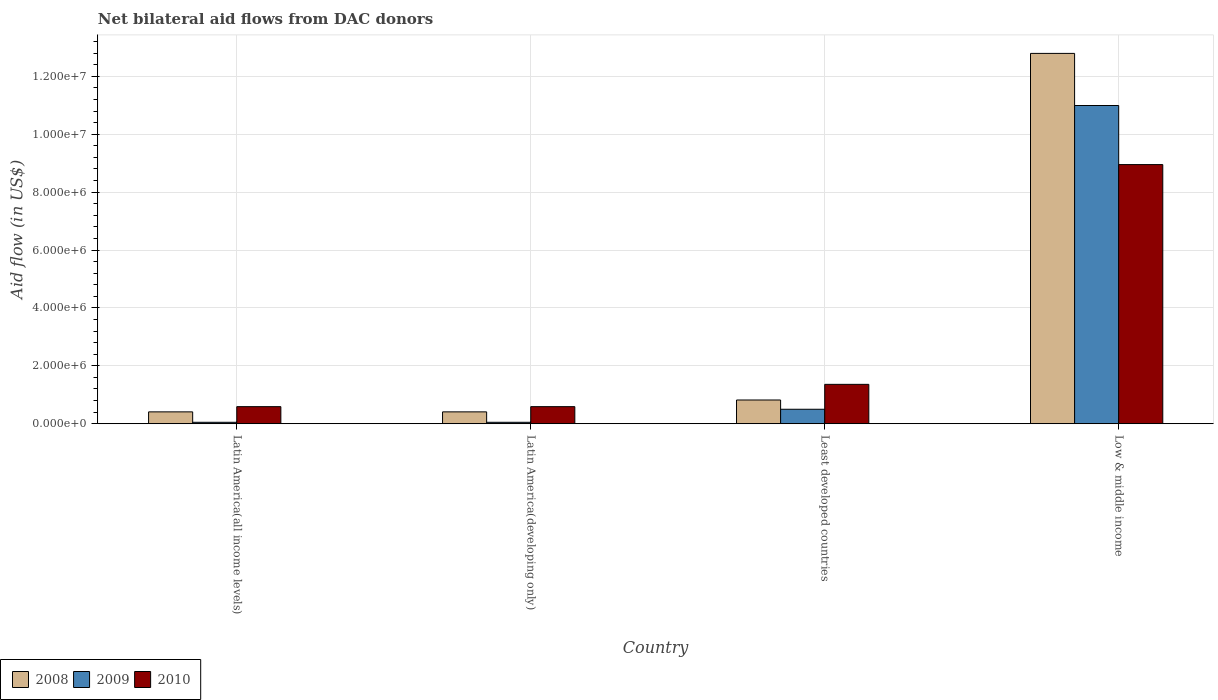How many different coloured bars are there?
Give a very brief answer. 3. How many groups of bars are there?
Your answer should be compact. 4. How many bars are there on the 3rd tick from the right?
Make the answer very short. 3. What is the label of the 1st group of bars from the left?
Keep it short and to the point. Latin America(all income levels). What is the net bilateral aid flow in 2008 in Low & middle income?
Give a very brief answer. 1.28e+07. Across all countries, what is the maximum net bilateral aid flow in 2009?
Ensure brevity in your answer.  1.10e+07. In which country was the net bilateral aid flow in 2008 maximum?
Provide a succinct answer. Low & middle income. In which country was the net bilateral aid flow in 2008 minimum?
Make the answer very short. Latin America(all income levels). What is the total net bilateral aid flow in 2010 in the graph?
Offer a terse response. 1.15e+07. What is the difference between the net bilateral aid flow in 2010 in Latin America(all income levels) and that in Low & middle income?
Provide a succinct answer. -8.36e+06. What is the difference between the net bilateral aid flow in 2008 in Least developed countries and the net bilateral aid flow in 2010 in Latin America(developing only)?
Your answer should be compact. 2.30e+05. What is the average net bilateral aid flow in 2008 per country?
Offer a terse response. 3.61e+06. What is the difference between the net bilateral aid flow of/in 2008 and net bilateral aid flow of/in 2010 in Low & middle income?
Offer a very short reply. 3.84e+06. Is the difference between the net bilateral aid flow in 2008 in Latin America(developing only) and Low & middle income greater than the difference between the net bilateral aid flow in 2010 in Latin America(developing only) and Low & middle income?
Provide a short and direct response. No. What is the difference between the highest and the second highest net bilateral aid flow in 2010?
Make the answer very short. 7.59e+06. What is the difference between the highest and the lowest net bilateral aid flow in 2010?
Offer a very short reply. 8.36e+06. What does the 2nd bar from the left in Least developed countries represents?
Keep it short and to the point. 2009. How many bars are there?
Offer a terse response. 12. Are the values on the major ticks of Y-axis written in scientific E-notation?
Provide a short and direct response. Yes. Where does the legend appear in the graph?
Keep it short and to the point. Bottom left. How are the legend labels stacked?
Make the answer very short. Horizontal. What is the title of the graph?
Make the answer very short. Net bilateral aid flows from DAC donors. Does "1977" appear as one of the legend labels in the graph?
Your response must be concise. No. What is the label or title of the Y-axis?
Your answer should be compact. Aid flow (in US$). What is the Aid flow (in US$) of 2008 in Latin America(all income levels)?
Offer a terse response. 4.10e+05. What is the Aid flow (in US$) in 2010 in Latin America(all income levels)?
Your answer should be compact. 5.90e+05. What is the Aid flow (in US$) in 2008 in Latin America(developing only)?
Make the answer very short. 4.10e+05. What is the Aid flow (in US$) in 2009 in Latin America(developing only)?
Ensure brevity in your answer.  5.00e+04. What is the Aid flow (in US$) in 2010 in Latin America(developing only)?
Ensure brevity in your answer.  5.90e+05. What is the Aid flow (in US$) in 2008 in Least developed countries?
Your answer should be compact. 8.20e+05. What is the Aid flow (in US$) in 2009 in Least developed countries?
Keep it short and to the point. 5.00e+05. What is the Aid flow (in US$) of 2010 in Least developed countries?
Your response must be concise. 1.36e+06. What is the Aid flow (in US$) in 2008 in Low & middle income?
Offer a very short reply. 1.28e+07. What is the Aid flow (in US$) of 2009 in Low & middle income?
Keep it short and to the point. 1.10e+07. What is the Aid flow (in US$) of 2010 in Low & middle income?
Provide a succinct answer. 8.95e+06. Across all countries, what is the maximum Aid flow (in US$) in 2008?
Give a very brief answer. 1.28e+07. Across all countries, what is the maximum Aid flow (in US$) of 2009?
Keep it short and to the point. 1.10e+07. Across all countries, what is the maximum Aid flow (in US$) of 2010?
Offer a terse response. 8.95e+06. Across all countries, what is the minimum Aid flow (in US$) of 2010?
Keep it short and to the point. 5.90e+05. What is the total Aid flow (in US$) in 2008 in the graph?
Your answer should be very brief. 1.44e+07. What is the total Aid flow (in US$) of 2009 in the graph?
Make the answer very short. 1.16e+07. What is the total Aid flow (in US$) in 2010 in the graph?
Provide a succinct answer. 1.15e+07. What is the difference between the Aid flow (in US$) of 2009 in Latin America(all income levels) and that in Latin America(developing only)?
Keep it short and to the point. 0. What is the difference between the Aid flow (in US$) in 2008 in Latin America(all income levels) and that in Least developed countries?
Give a very brief answer. -4.10e+05. What is the difference between the Aid flow (in US$) in 2009 in Latin America(all income levels) and that in Least developed countries?
Offer a very short reply. -4.50e+05. What is the difference between the Aid flow (in US$) of 2010 in Latin America(all income levels) and that in Least developed countries?
Provide a succinct answer. -7.70e+05. What is the difference between the Aid flow (in US$) of 2008 in Latin America(all income levels) and that in Low & middle income?
Give a very brief answer. -1.24e+07. What is the difference between the Aid flow (in US$) in 2009 in Latin America(all income levels) and that in Low & middle income?
Offer a very short reply. -1.09e+07. What is the difference between the Aid flow (in US$) of 2010 in Latin America(all income levels) and that in Low & middle income?
Offer a very short reply. -8.36e+06. What is the difference between the Aid flow (in US$) in 2008 in Latin America(developing only) and that in Least developed countries?
Give a very brief answer. -4.10e+05. What is the difference between the Aid flow (in US$) in 2009 in Latin America(developing only) and that in Least developed countries?
Provide a succinct answer. -4.50e+05. What is the difference between the Aid flow (in US$) of 2010 in Latin America(developing only) and that in Least developed countries?
Offer a terse response. -7.70e+05. What is the difference between the Aid flow (in US$) of 2008 in Latin America(developing only) and that in Low & middle income?
Provide a succinct answer. -1.24e+07. What is the difference between the Aid flow (in US$) of 2009 in Latin America(developing only) and that in Low & middle income?
Provide a short and direct response. -1.09e+07. What is the difference between the Aid flow (in US$) of 2010 in Latin America(developing only) and that in Low & middle income?
Offer a very short reply. -8.36e+06. What is the difference between the Aid flow (in US$) in 2008 in Least developed countries and that in Low & middle income?
Provide a short and direct response. -1.20e+07. What is the difference between the Aid flow (in US$) in 2009 in Least developed countries and that in Low & middle income?
Give a very brief answer. -1.05e+07. What is the difference between the Aid flow (in US$) in 2010 in Least developed countries and that in Low & middle income?
Your response must be concise. -7.59e+06. What is the difference between the Aid flow (in US$) of 2008 in Latin America(all income levels) and the Aid flow (in US$) of 2009 in Latin America(developing only)?
Provide a short and direct response. 3.60e+05. What is the difference between the Aid flow (in US$) of 2009 in Latin America(all income levels) and the Aid flow (in US$) of 2010 in Latin America(developing only)?
Offer a terse response. -5.40e+05. What is the difference between the Aid flow (in US$) in 2008 in Latin America(all income levels) and the Aid flow (in US$) in 2009 in Least developed countries?
Provide a short and direct response. -9.00e+04. What is the difference between the Aid flow (in US$) of 2008 in Latin America(all income levels) and the Aid flow (in US$) of 2010 in Least developed countries?
Keep it short and to the point. -9.50e+05. What is the difference between the Aid flow (in US$) of 2009 in Latin America(all income levels) and the Aid flow (in US$) of 2010 in Least developed countries?
Provide a short and direct response. -1.31e+06. What is the difference between the Aid flow (in US$) in 2008 in Latin America(all income levels) and the Aid flow (in US$) in 2009 in Low & middle income?
Offer a very short reply. -1.06e+07. What is the difference between the Aid flow (in US$) of 2008 in Latin America(all income levels) and the Aid flow (in US$) of 2010 in Low & middle income?
Provide a succinct answer. -8.54e+06. What is the difference between the Aid flow (in US$) in 2009 in Latin America(all income levels) and the Aid flow (in US$) in 2010 in Low & middle income?
Give a very brief answer. -8.90e+06. What is the difference between the Aid flow (in US$) in 2008 in Latin America(developing only) and the Aid flow (in US$) in 2009 in Least developed countries?
Ensure brevity in your answer.  -9.00e+04. What is the difference between the Aid flow (in US$) in 2008 in Latin America(developing only) and the Aid flow (in US$) in 2010 in Least developed countries?
Ensure brevity in your answer.  -9.50e+05. What is the difference between the Aid flow (in US$) of 2009 in Latin America(developing only) and the Aid flow (in US$) of 2010 in Least developed countries?
Ensure brevity in your answer.  -1.31e+06. What is the difference between the Aid flow (in US$) in 2008 in Latin America(developing only) and the Aid flow (in US$) in 2009 in Low & middle income?
Offer a terse response. -1.06e+07. What is the difference between the Aid flow (in US$) in 2008 in Latin America(developing only) and the Aid flow (in US$) in 2010 in Low & middle income?
Provide a succinct answer. -8.54e+06. What is the difference between the Aid flow (in US$) in 2009 in Latin America(developing only) and the Aid flow (in US$) in 2010 in Low & middle income?
Make the answer very short. -8.90e+06. What is the difference between the Aid flow (in US$) in 2008 in Least developed countries and the Aid flow (in US$) in 2009 in Low & middle income?
Offer a terse response. -1.02e+07. What is the difference between the Aid flow (in US$) of 2008 in Least developed countries and the Aid flow (in US$) of 2010 in Low & middle income?
Provide a short and direct response. -8.13e+06. What is the difference between the Aid flow (in US$) in 2009 in Least developed countries and the Aid flow (in US$) in 2010 in Low & middle income?
Keep it short and to the point. -8.45e+06. What is the average Aid flow (in US$) of 2008 per country?
Provide a short and direct response. 3.61e+06. What is the average Aid flow (in US$) in 2009 per country?
Make the answer very short. 2.90e+06. What is the average Aid flow (in US$) of 2010 per country?
Provide a succinct answer. 2.87e+06. What is the difference between the Aid flow (in US$) of 2008 and Aid flow (in US$) of 2009 in Latin America(all income levels)?
Provide a short and direct response. 3.60e+05. What is the difference between the Aid flow (in US$) in 2008 and Aid flow (in US$) in 2010 in Latin America(all income levels)?
Offer a very short reply. -1.80e+05. What is the difference between the Aid flow (in US$) of 2009 and Aid flow (in US$) of 2010 in Latin America(all income levels)?
Keep it short and to the point. -5.40e+05. What is the difference between the Aid flow (in US$) of 2008 and Aid flow (in US$) of 2009 in Latin America(developing only)?
Offer a terse response. 3.60e+05. What is the difference between the Aid flow (in US$) of 2009 and Aid flow (in US$) of 2010 in Latin America(developing only)?
Ensure brevity in your answer.  -5.40e+05. What is the difference between the Aid flow (in US$) of 2008 and Aid flow (in US$) of 2010 in Least developed countries?
Provide a succinct answer. -5.40e+05. What is the difference between the Aid flow (in US$) of 2009 and Aid flow (in US$) of 2010 in Least developed countries?
Provide a succinct answer. -8.60e+05. What is the difference between the Aid flow (in US$) of 2008 and Aid flow (in US$) of 2009 in Low & middle income?
Offer a terse response. 1.80e+06. What is the difference between the Aid flow (in US$) in 2008 and Aid flow (in US$) in 2010 in Low & middle income?
Provide a short and direct response. 3.84e+06. What is the difference between the Aid flow (in US$) in 2009 and Aid flow (in US$) in 2010 in Low & middle income?
Offer a terse response. 2.04e+06. What is the ratio of the Aid flow (in US$) of 2008 in Latin America(all income levels) to that in Latin America(developing only)?
Provide a short and direct response. 1. What is the ratio of the Aid flow (in US$) of 2010 in Latin America(all income levels) to that in Latin America(developing only)?
Offer a terse response. 1. What is the ratio of the Aid flow (in US$) in 2008 in Latin America(all income levels) to that in Least developed countries?
Offer a terse response. 0.5. What is the ratio of the Aid flow (in US$) in 2010 in Latin America(all income levels) to that in Least developed countries?
Keep it short and to the point. 0.43. What is the ratio of the Aid flow (in US$) in 2008 in Latin America(all income levels) to that in Low & middle income?
Provide a short and direct response. 0.03. What is the ratio of the Aid flow (in US$) of 2009 in Latin America(all income levels) to that in Low & middle income?
Your answer should be compact. 0. What is the ratio of the Aid flow (in US$) in 2010 in Latin America(all income levels) to that in Low & middle income?
Ensure brevity in your answer.  0.07. What is the ratio of the Aid flow (in US$) in 2010 in Latin America(developing only) to that in Least developed countries?
Ensure brevity in your answer.  0.43. What is the ratio of the Aid flow (in US$) in 2008 in Latin America(developing only) to that in Low & middle income?
Give a very brief answer. 0.03. What is the ratio of the Aid flow (in US$) in 2009 in Latin America(developing only) to that in Low & middle income?
Provide a short and direct response. 0. What is the ratio of the Aid flow (in US$) of 2010 in Latin America(developing only) to that in Low & middle income?
Ensure brevity in your answer.  0.07. What is the ratio of the Aid flow (in US$) in 2008 in Least developed countries to that in Low & middle income?
Ensure brevity in your answer.  0.06. What is the ratio of the Aid flow (in US$) of 2009 in Least developed countries to that in Low & middle income?
Give a very brief answer. 0.05. What is the ratio of the Aid flow (in US$) in 2010 in Least developed countries to that in Low & middle income?
Provide a succinct answer. 0.15. What is the difference between the highest and the second highest Aid flow (in US$) of 2008?
Offer a terse response. 1.20e+07. What is the difference between the highest and the second highest Aid flow (in US$) of 2009?
Make the answer very short. 1.05e+07. What is the difference between the highest and the second highest Aid flow (in US$) of 2010?
Keep it short and to the point. 7.59e+06. What is the difference between the highest and the lowest Aid flow (in US$) of 2008?
Provide a short and direct response. 1.24e+07. What is the difference between the highest and the lowest Aid flow (in US$) of 2009?
Offer a terse response. 1.09e+07. What is the difference between the highest and the lowest Aid flow (in US$) in 2010?
Your answer should be very brief. 8.36e+06. 